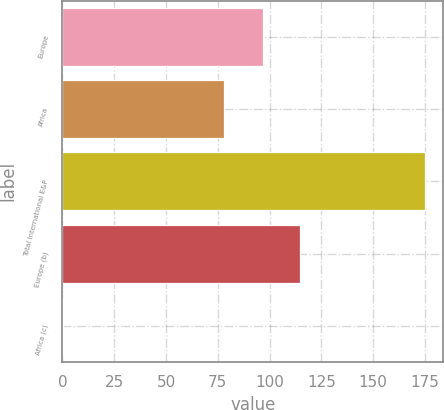<chart> <loc_0><loc_0><loc_500><loc_500><bar_chart><fcel>Europe<fcel>Africa<fcel>Total International E&P<fcel>Europe (b)<fcel>Africa (c)<nl><fcel>97<fcel>78<fcel>175<fcel>114.46<fcel>0.43<nl></chart> 